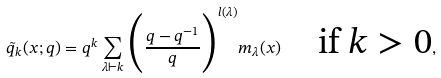Convert formula to latex. <formula><loc_0><loc_0><loc_500><loc_500>\tilde { q } _ { k } ( x ; q ) = q ^ { k } \sum _ { \lambda { \vdash } k } \Big { ( } \frac { q - q ^ { - 1 } } { q } \Big { ) } ^ { l ( { \lambda } ) } m _ { \lambda } ( x ) { \quad } \text {if $k>0$} ,</formula> 